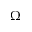Convert formula to latex. <formula><loc_0><loc_0><loc_500><loc_500>\Omega</formula> 